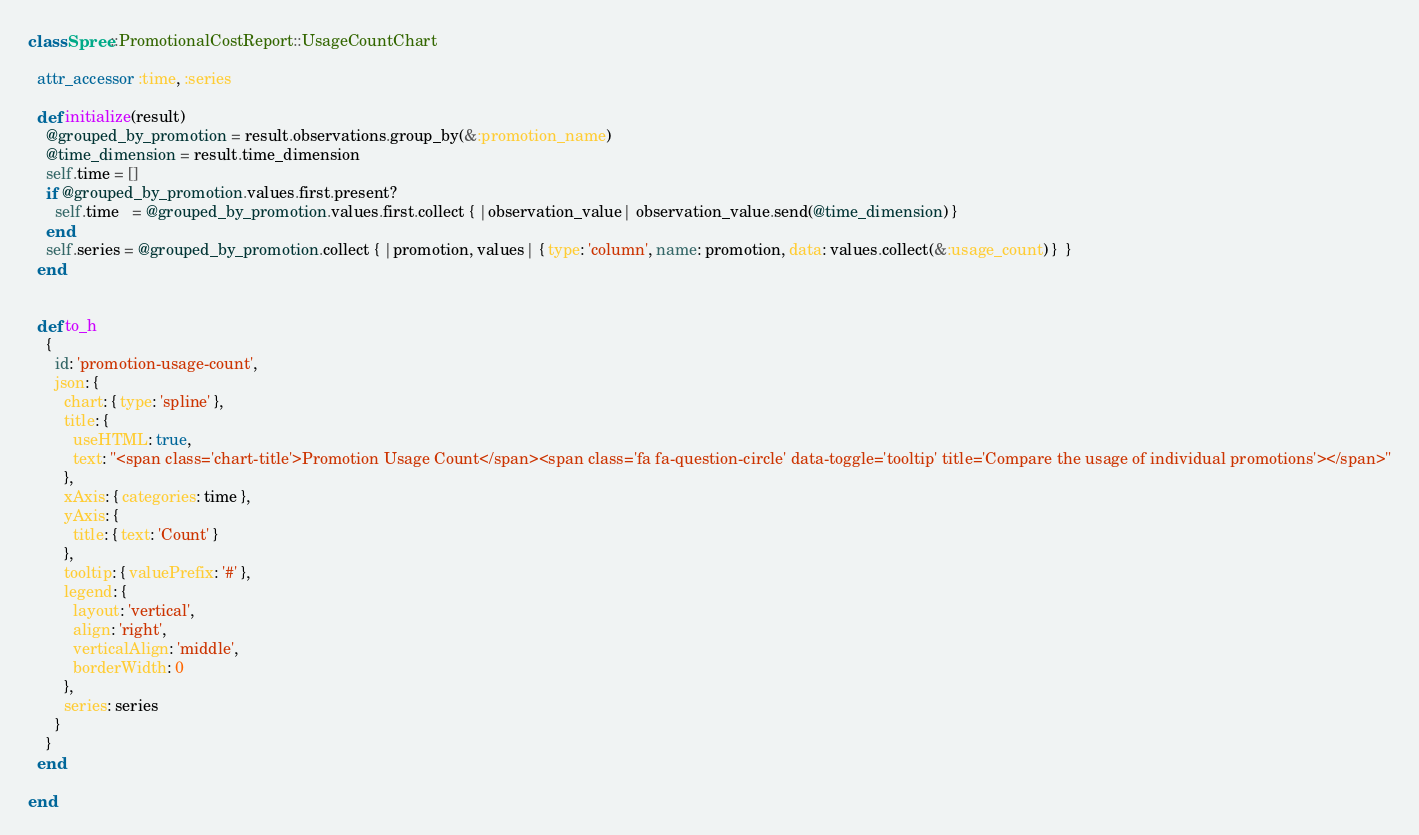Convert code to text. <code><loc_0><loc_0><loc_500><loc_500><_Ruby_>class Spree::PromotionalCostReport::UsageCountChart

  attr_accessor :time, :series

  def initialize(result)
    @grouped_by_promotion = result.observations.group_by(&:promotion_name)
    @time_dimension = result.time_dimension
    self.time = []
    if @grouped_by_promotion.values.first.present?
      self.time   = @grouped_by_promotion.values.first.collect { |observation_value| observation_value.send(@time_dimension) }
    end
    self.series = @grouped_by_promotion.collect { |promotion, values| { type: 'column', name: promotion, data: values.collect(&:usage_count) }  }
  end


  def to_h
    {
      id: 'promotion-usage-count',
      json: {
        chart: { type: 'spline' },
        title: {
          useHTML: true,
          text: "<span class='chart-title'>Promotion Usage Count</span><span class='fa fa-question-circle' data-toggle='tooltip' title='Compare the usage of individual promotions'></span>"
        },
        xAxis: { categories: time },
        yAxis: {
          title: { text: 'Count' }
        },
        tooltip: { valuePrefix: '#' },
        legend: {
          layout: 'vertical',
          align: 'right',
          verticalAlign: 'middle',
          borderWidth: 0
        },
        series: series
      }
    }
  end

end
</code> 